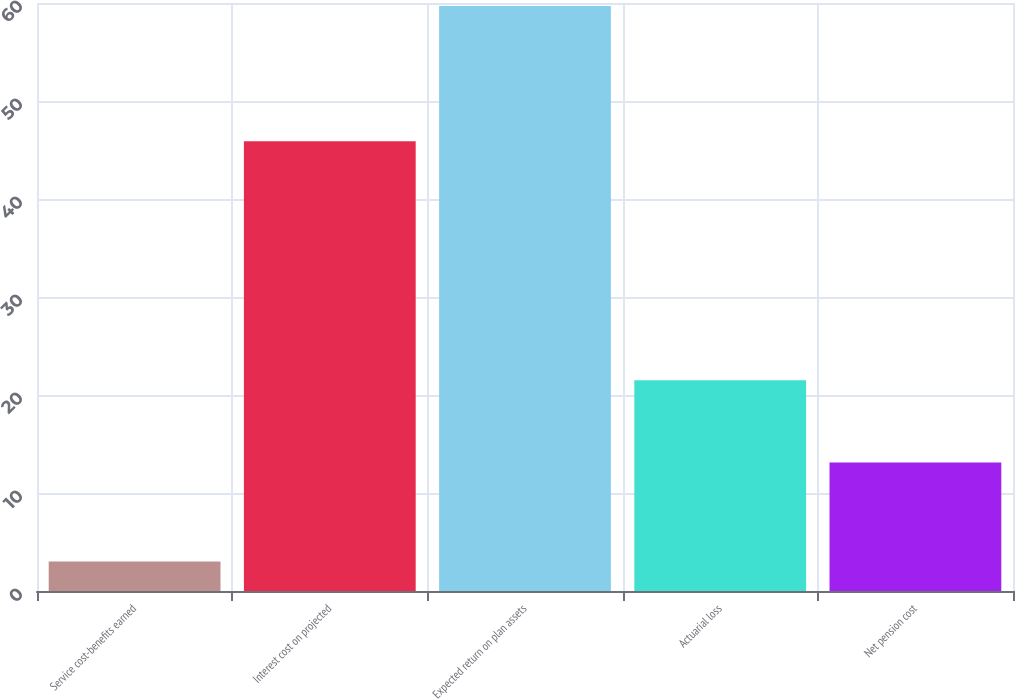Convert chart to OTSL. <chart><loc_0><loc_0><loc_500><loc_500><bar_chart><fcel>Service cost-benefits earned<fcel>Interest cost on projected<fcel>Expected return on plan assets<fcel>Actuarial loss<fcel>Net pension cost<nl><fcel>3<fcel>45.9<fcel>59.7<fcel>21.5<fcel>13.1<nl></chart> 